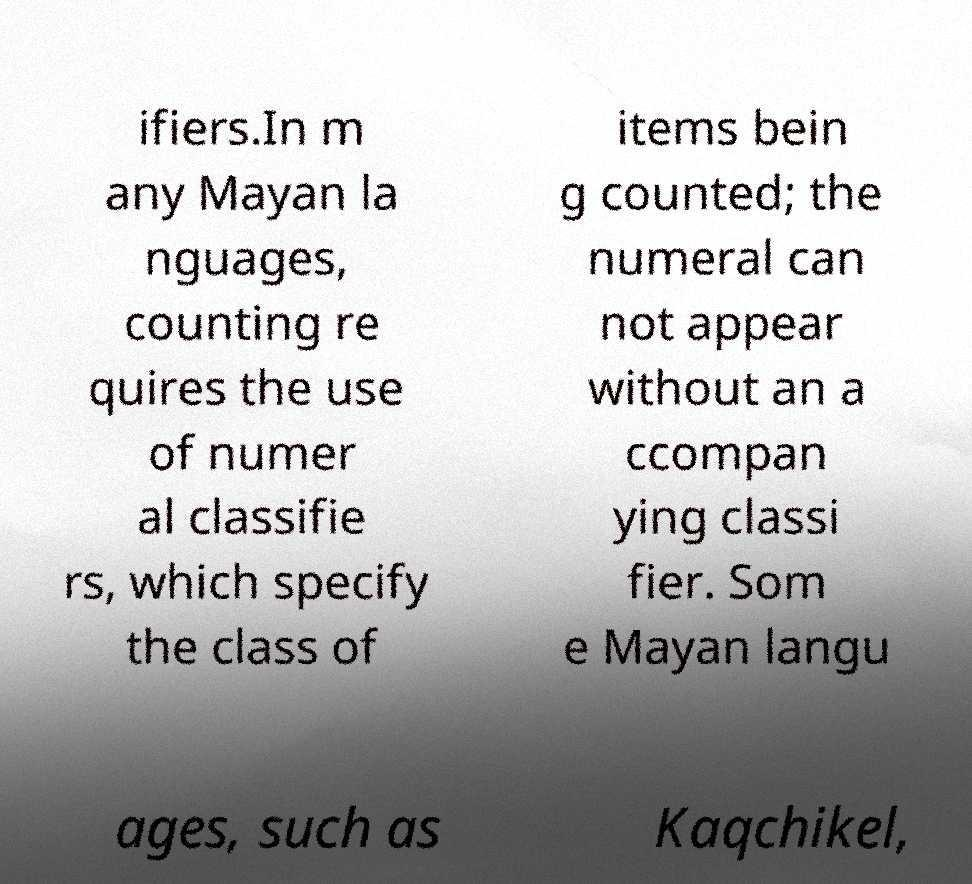For documentation purposes, I need the text within this image transcribed. Could you provide that? ifiers.In m any Mayan la nguages, counting re quires the use of numer al classifie rs, which specify the class of items bein g counted; the numeral can not appear without an a ccompan ying classi fier. Som e Mayan langu ages, such as Kaqchikel, 